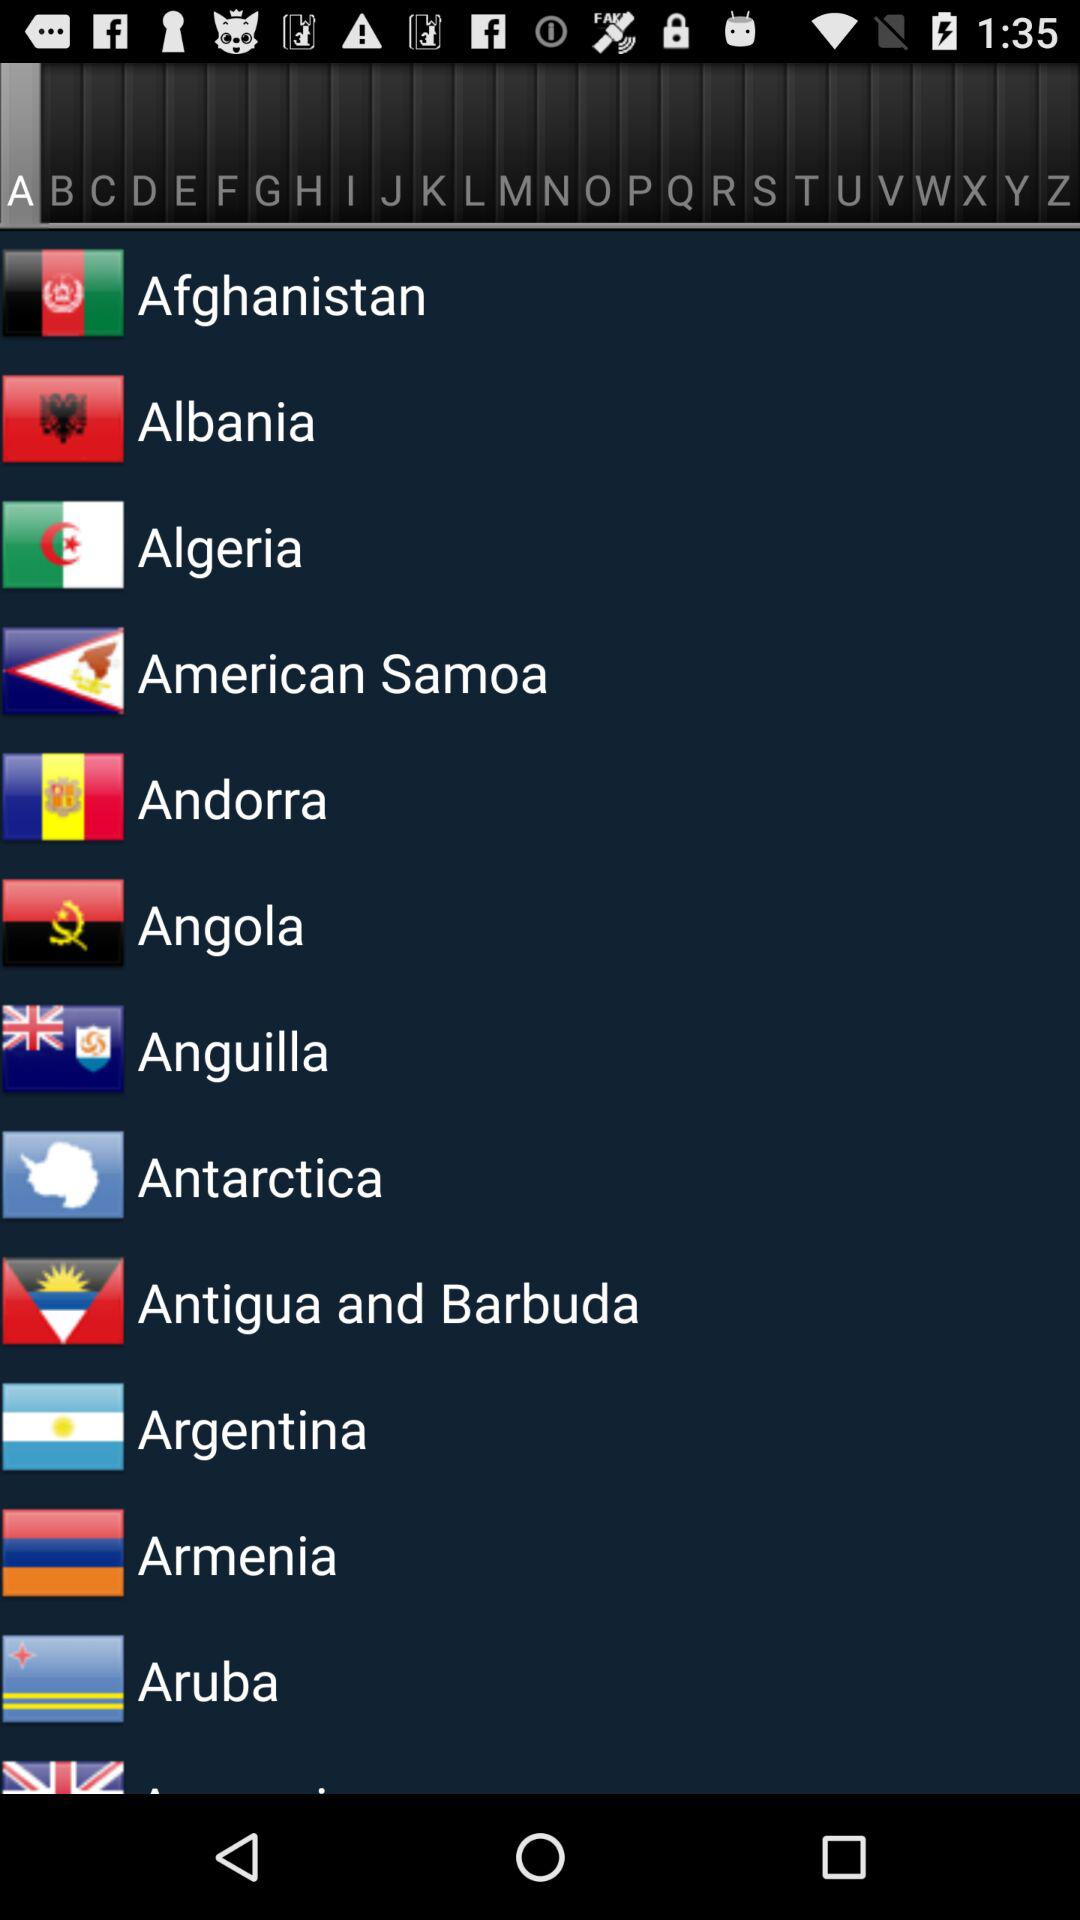Which tab is selected? The selected tab is "A". 